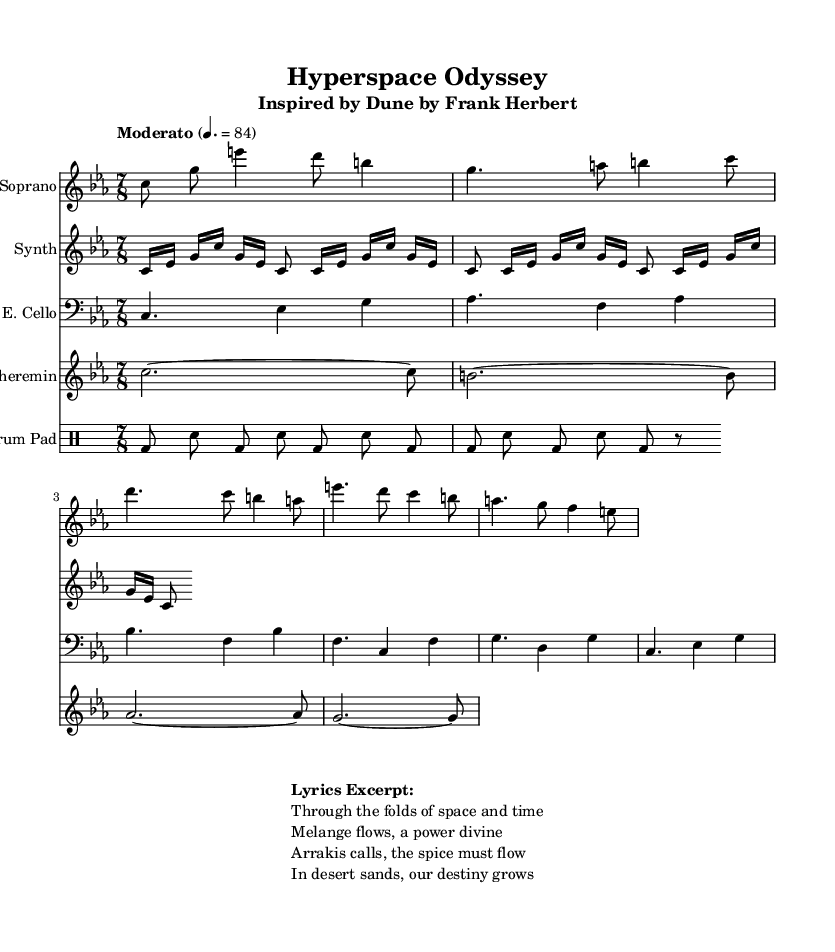What is the key signature of this music? The key signature is C minor, which has three flats (B flat, E flat, A flat). This can be identified in the key signature section of the staff at the beginning of the score.
Answer: C minor What is the time signature of the piece? The time signature is 7/8, which indicates there are seven eighth notes in each measure. This is shown at the beginning of the score, next to the key signature.
Answer: 7/8 What is the tempo marking for this opera? The tempo of the piece is marked as "Moderato" with a metronome marking of 84 beats per minute, indicating a moderate speed. This can be found below the title in the tempo indication.
Answer: Moderato 4. = 84 How many measures are there in the soprano voice section? By counting the distinct sets of notes and measures within the soprano voice staff, there are a total of five measures present in the provided excerpt of the soprano part.
Answer: 5 Which instruments are featured in this score? The instruments indicated are Soprano, Synthesizer, Electric Cello, Theremin, and an Electronic Drum Pad, all listed at the beginning of their respective staves.
Answer: Soprano, Synth, E. Cello, Theremin, Drum Pad What type of musical genre does this sheet music belong to? The score exemplifies the genre of opera, specifically a contemporary opera that draws from classic science fiction novels, as indicated by the title and subtitle. This is apparent from the header of the score.
Answer: Opera What is a unique characteristic of the music structure in this opera? The use of an avant-garde electronic music style, characterized by synthesizer parts and electronic drum patterns, creates an unusual and innovative approach, distinguishing it from traditional operas. This can be inferred from the instrumental indications and electronic elements present.
Answer: Avant-garde electronic music 